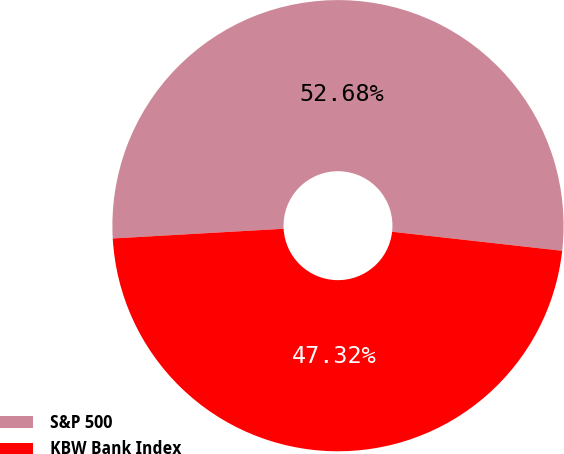Convert chart to OTSL. <chart><loc_0><loc_0><loc_500><loc_500><pie_chart><fcel>S&P 500<fcel>KBW Bank Index<nl><fcel>52.68%<fcel>47.32%<nl></chart> 